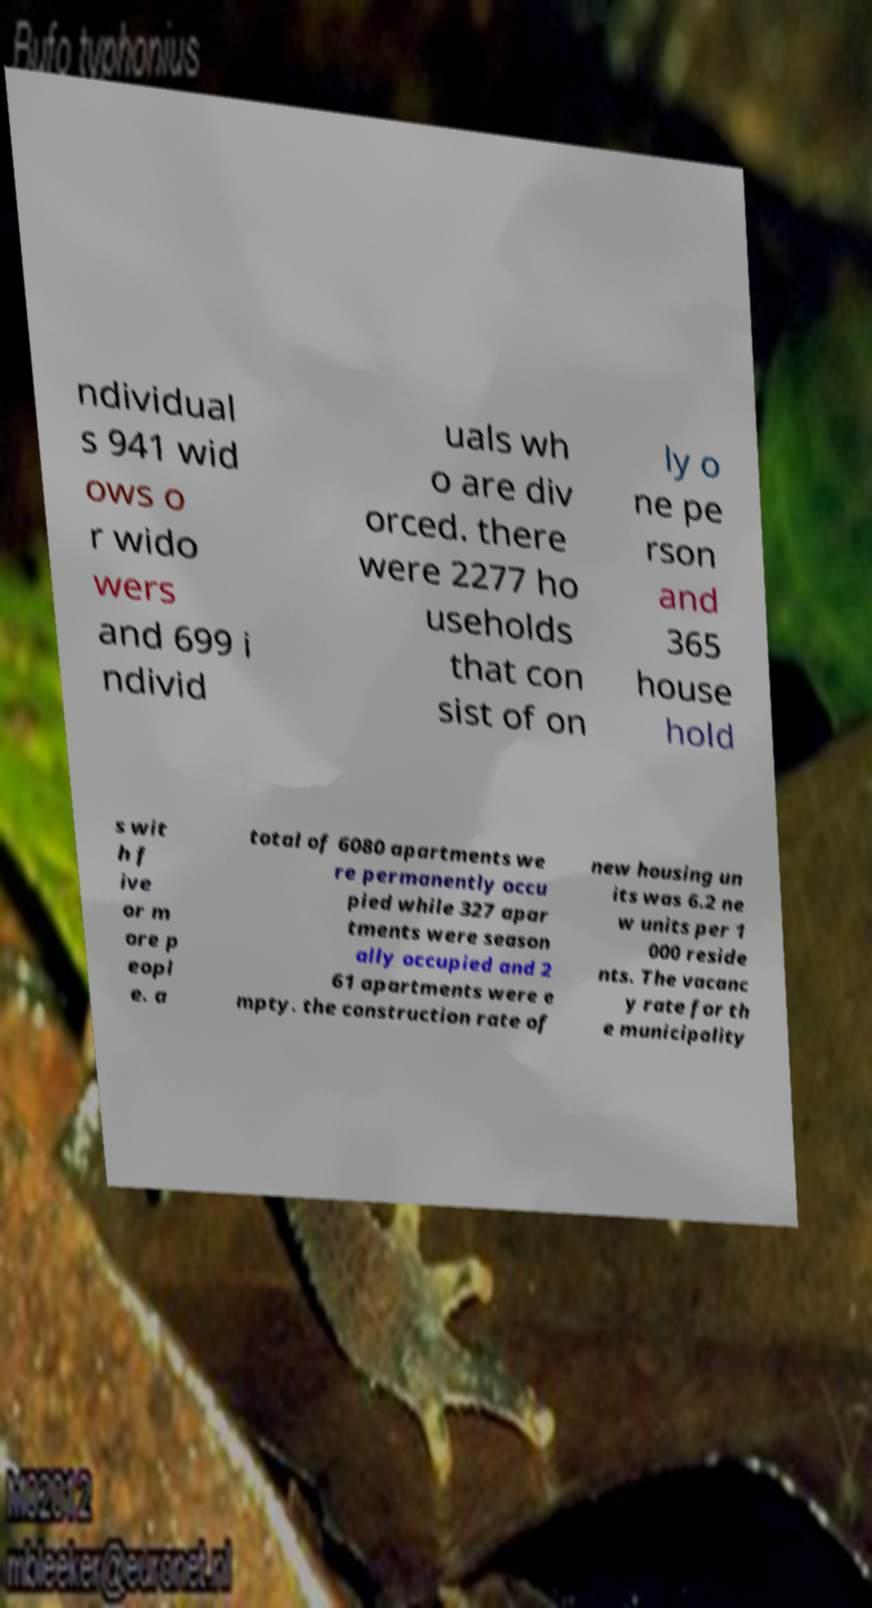For documentation purposes, I need the text within this image transcribed. Could you provide that? ndividual s 941 wid ows o r wido wers and 699 i ndivid uals wh o are div orced. there were 2277 ho useholds that con sist of on ly o ne pe rson and 365 house hold s wit h f ive or m ore p eopl e. a total of 6080 apartments we re permanently occu pied while 327 apar tments were season ally occupied and 2 61 apartments were e mpty. the construction rate of new housing un its was 6.2 ne w units per 1 000 reside nts. The vacanc y rate for th e municipality 